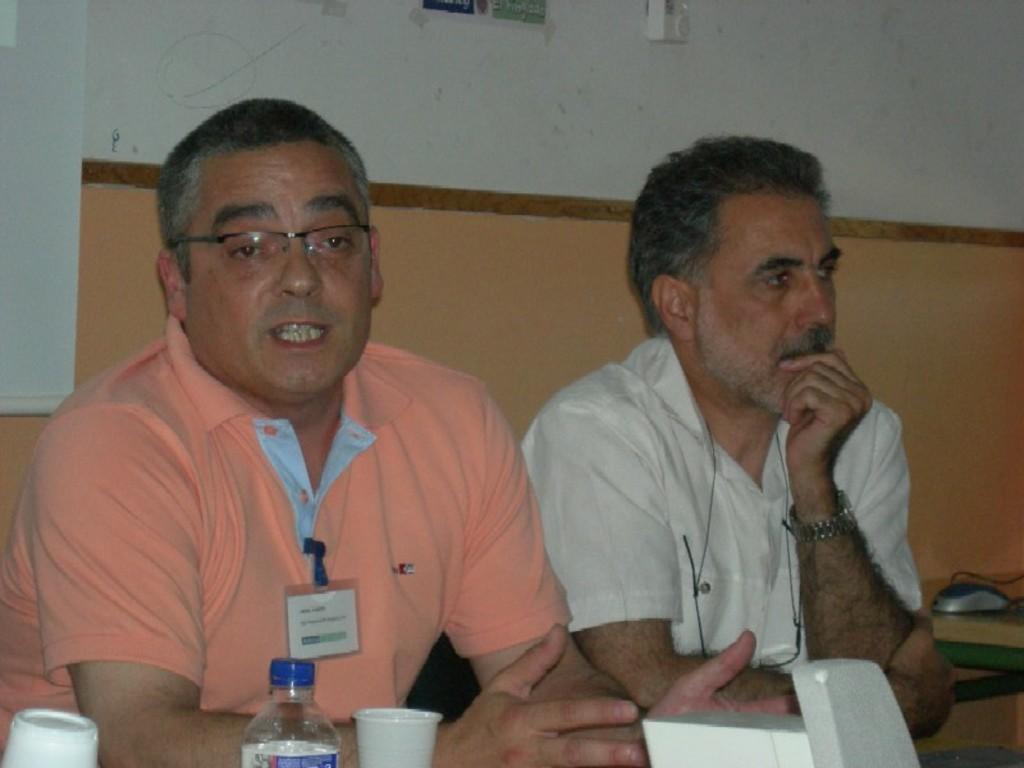How would you summarize this image in a sentence or two? In the foreground, I can see two persons are sitting on the chairs in front of a table on which glasses, bottle and some objects are there. In the background, I can see a wall. This image might be taken in a hall. 